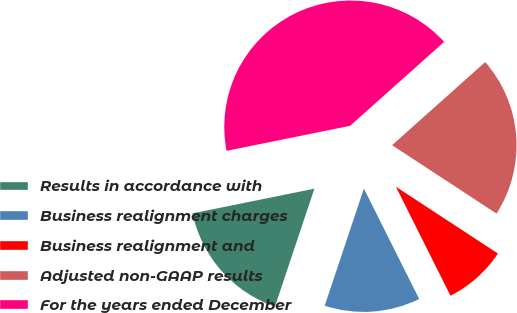Convert chart. <chart><loc_0><loc_0><loc_500><loc_500><pie_chart><fcel>Results in accordance with<fcel>Business realignment charges<fcel>Business realignment and<fcel>Adjusted non-GAAP results<fcel>For the years ended December<nl><fcel>16.68%<fcel>12.53%<fcel>8.38%<fcel>20.83%<fcel>41.58%<nl></chart> 